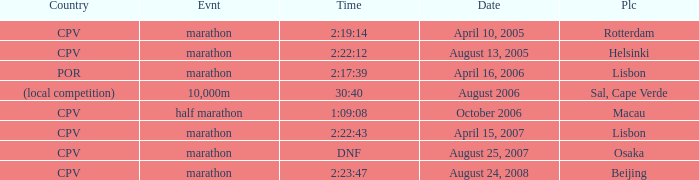Write the full table. {'header': ['Country', 'Evnt', 'Time', 'Date', 'Plc'], 'rows': [['CPV', 'marathon', '2:19:14', 'April 10, 2005', 'Rotterdam'], ['CPV', 'marathon', '2:22:12', 'August 13, 2005', 'Helsinki'], ['POR', 'marathon', '2:17:39', 'April 16, 2006', 'Lisbon'], ['(local competition)', '10,000m', '30:40', 'August 2006', 'Sal, Cape Verde'], ['CPV', 'half marathon', '1:09:08', 'October 2006', 'Macau'], ['CPV', 'marathon', '2:22:43', 'April 15, 2007', 'Lisbon'], ['CPV', 'marathon', 'DNF', 'August 25, 2007', 'Osaka'], ['CPV', 'marathon', '2:23:47', 'August 24, 2008', 'Beijing']]} What is the Date of the Event with a Time of 2:23:47? August 24, 2008. 